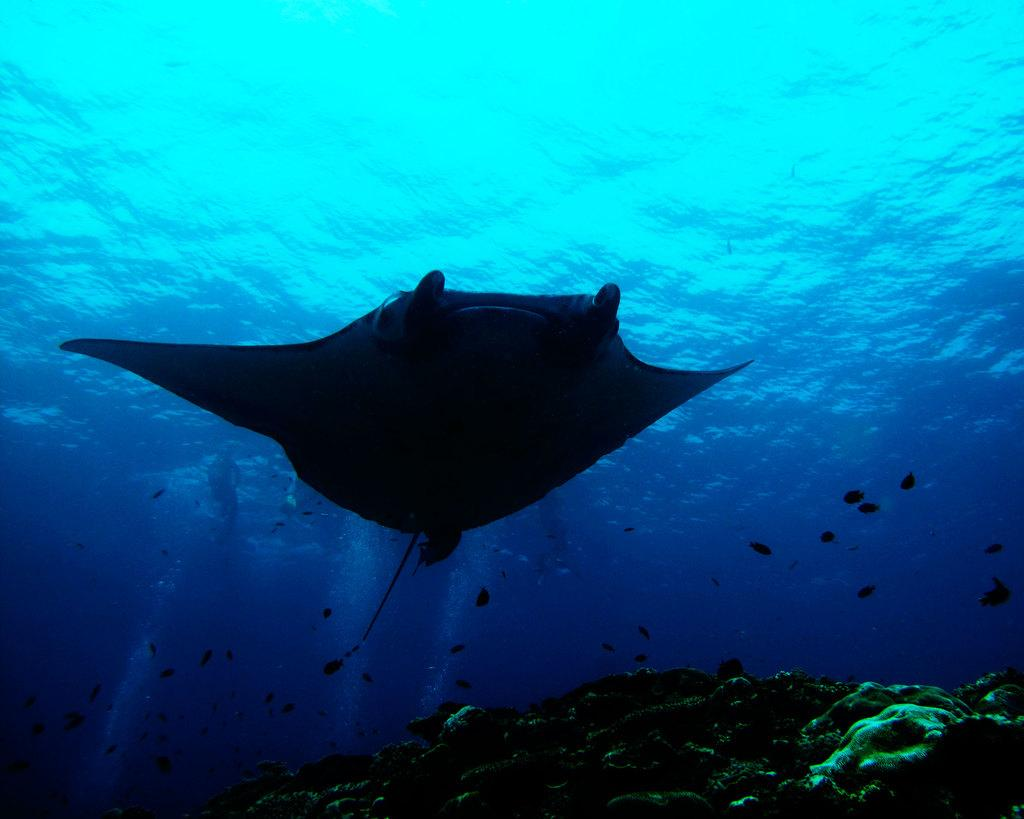What is happening in the water in the image? There are fishes swimming in the water. What can be seen on the right side of the image? There are rocks on the right side of the image. What color is the orange floating in the water? There is no orange present in the image; it only features fishes swimming in the water and rocks on the right side. 